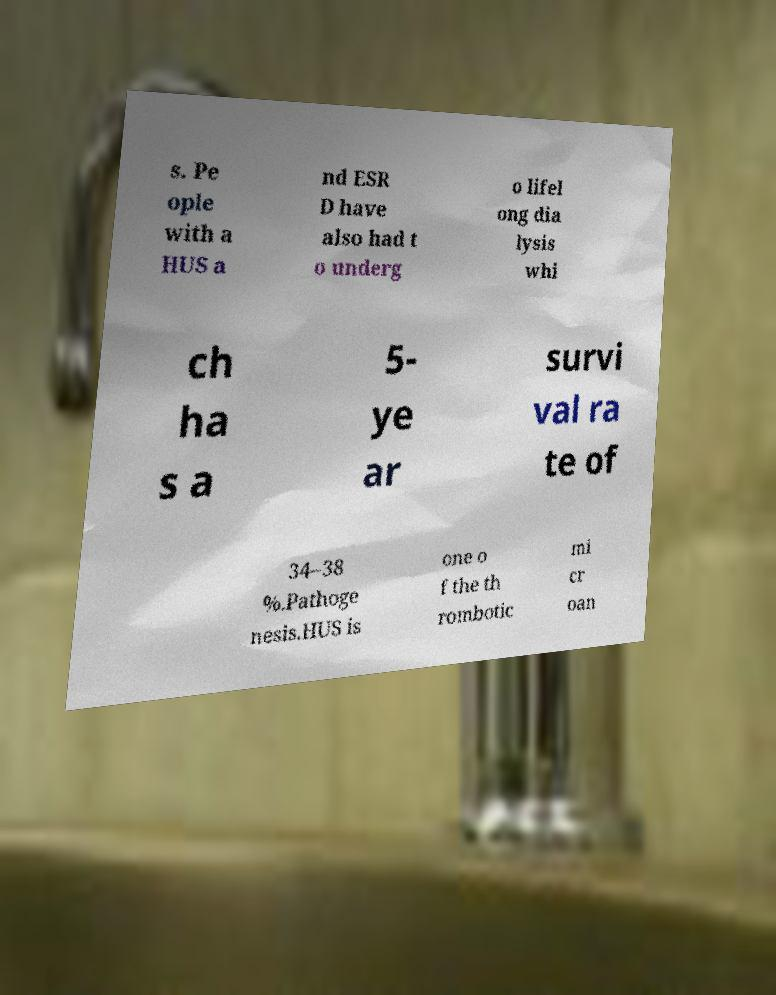Can you read and provide the text displayed in the image?This photo seems to have some interesting text. Can you extract and type it out for me? s. Pe ople with a HUS a nd ESR D have also had t o underg o lifel ong dia lysis whi ch ha s a 5- ye ar survi val ra te of 34–38 %.Pathoge nesis.HUS is one o f the th rombotic mi cr oan 